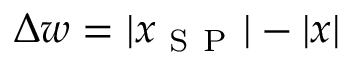Convert formula to latex. <formula><loc_0><loc_0><loc_500><loc_500>\Delta w = | x _ { S P } | - | x |</formula> 